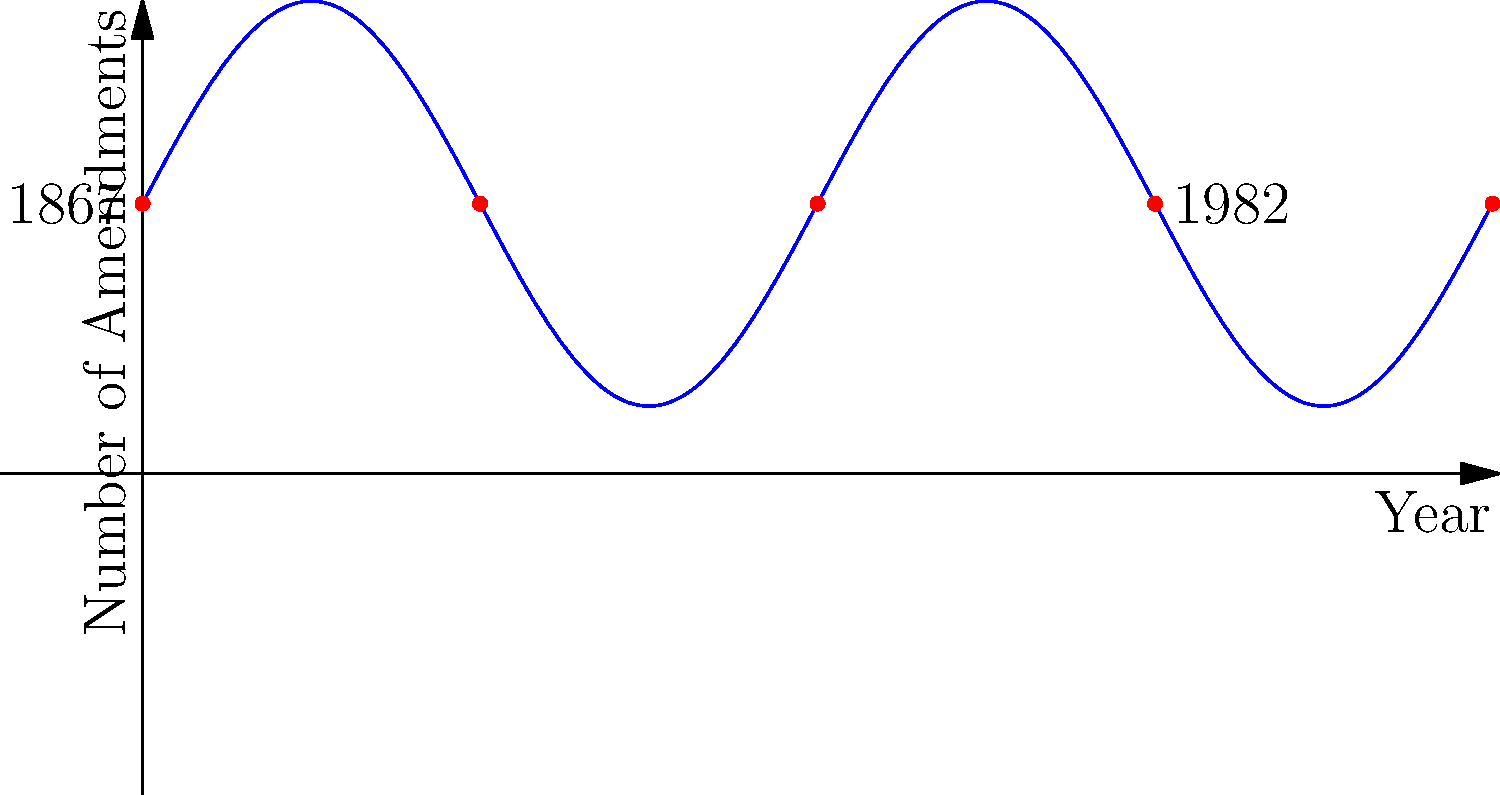The graph represents a simplified model of constitutional amendments in Canadian history from 1867 to the present day. The sine wave pattern suggests cyclical trends in amendment frequency. If this pattern continues, approximately how many years after 1982 (when the Constitution Act was patriated) would we expect to see the next peak in amendment activity? To solve this problem, we need to analyze the sine wave pattern and determine its period:

1. The sine function used in the model is of the form:
   $f(x) = 3\sin(\frac{\pi x}{5}) + 4$

2. For a general sine function $a\sin(bx) + c$, the period is given by $\frac{2\pi}{b}$.

3. In our case, $b = \frac{\pi}{5}$, so the period is:
   $\frac{2\pi}{\frac{\pi}{5}} = 10$ years

4. This means the cycle of amendment activity repeats every 10 years.

5. 1982 is represented at x = 15 on the graph (3/4 of the way from 1867 to the present).

6. The next peak would occur 5 years after 1982 (half the period of 10 years).

Therefore, we would expect to see the next peak in amendment activity approximately 5 years after 1982.
Answer: 5 years 